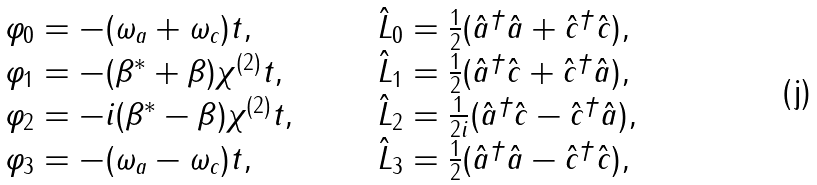Convert formula to latex. <formula><loc_0><loc_0><loc_500><loc_500>\begin{array} { l l } \varphi _ { 0 } = - ( \omega _ { a } + \omega _ { c } ) t , \quad & \quad \hat { L } _ { 0 } = \frac { 1 } { 2 } ( \hat { a } ^ { \dagger } \hat { a } + \hat { c } ^ { \dagger } \hat { c } ) , \\ \varphi _ { 1 } = - ( \beta ^ { * } + \beta ) \chi ^ { ( 2 ) } t , \quad & \quad \hat { L } _ { 1 } = \frac { 1 } { 2 } ( \hat { a } ^ { \dagger } \hat { c } + \hat { c } ^ { \dagger } \hat { a } ) , \\ \varphi _ { 2 } = - i ( \beta ^ { * } - \beta ) \chi ^ { ( 2 ) } t , \quad & \quad \hat { L } _ { 2 } = \frac { 1 } { 2 i } ( \hat { a } ^ { \dagger } \hat { c } - \hat { c } ^ { \dagger } \hat { a } ) , \\ \varphi _ { 3 } = - ( \omega _ { a } - \omega _ { c } ) t , \quad & \quad \hat { L } _ { 3 } = \frac { 1 } { 2 } ( \hat { a } ^ { \dagger } \hat { a } - \hat { c } ^ { \dagger } \hat { c } ) , \end{array}</formula> 